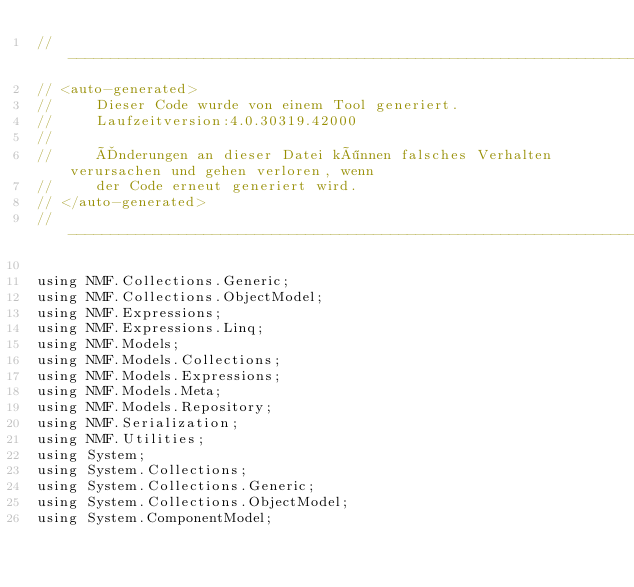<code> <loc_0><loc_0><loc_500><loc_500><_C#_>//------------------------------------------------------------------------------
// <auto-generated>
//     Dieser Code wurde von einem Tool generiert.
//     Laufzeitversion:4.0.30319.42000
//
//     Änderungen an dieser Datei können falsches Verhalten verursachen und gehen verloren, wenn
//     der Code erneut generiert wird.
// </auto-generated>
//------------------------------------------------------------------------------

using NMF.Collections.Generic;
using NMF.Collections.ObjectModel;
using NMF.Expressions;
using NMF.Expressions.Linq;
using NMF.Models;
using NMF.Models.Collections;
using NMF.Models.Expressions;
using NMF.Models.Meta;
using NMF.Models.Repository;
using NMF.Serialization;
using NMF.Utilities;
using System;
using System.Collections;
using System.Collections.Generic;
using System.Collections.ObjectModel;
using System.ComponentModel;</code> 